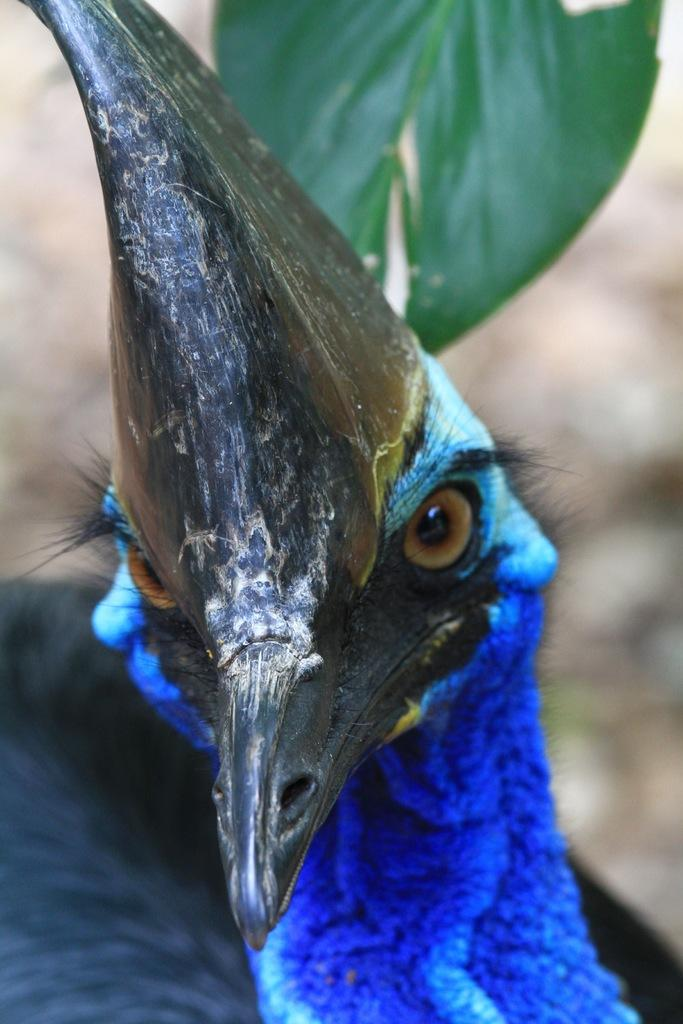What is the main subject of the image? There is a peacock in the center of the image. Can you describe the background of the image? There is a leaf in the background of the image. How many cabbages can be seen in the image? There are no cabbages present in the image. What is the quickest way to reach the end of the image? The concept of reaching the end of the image is not applicable, as it is a two-dimensional representation. 